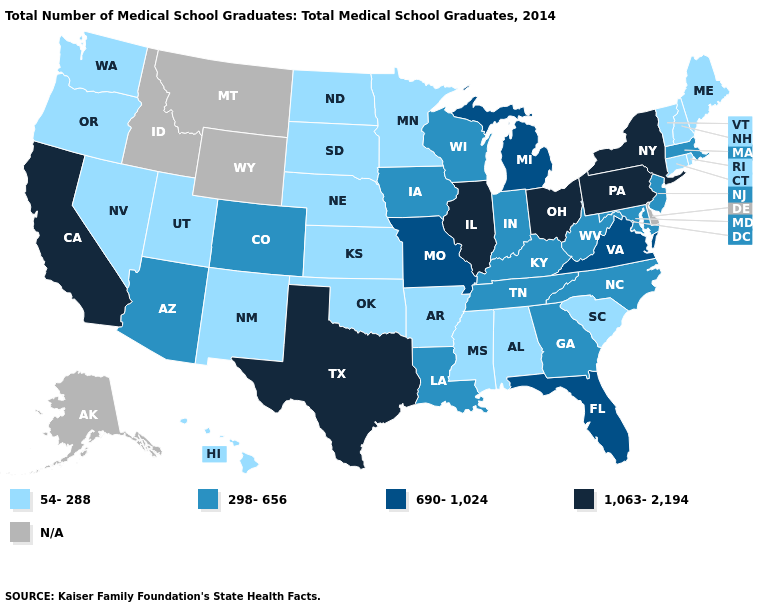How many symbols are there in the legend?
Be succinct. 5. Name the states that have a value in the range N/A?
Give a very brief answer. Alaska, Delaware, Idaho, Montana, Wyoming. What is the value of South Carolina?
Concise answer only. 54-288. What is the value of Nevada?
Be succinct. 54-288. Which states have the highest value in the USA?
Give a very brief answer. California, Illinois, New York, Ohio, Pennsylvania, Texas. Name the states that have a value in the range 690-1,024?
Quick response, please. Florida, Michigan, Missouri, Virginia. Name the states that have a value in the range 298-656?
Short answer required. Arizona, Colorado, Georgia, Indiana, Iowa, Kentucky, Louisiana, Maryland, Massachusetts, New Jersey, North Carolina, Tennessee, West Virginia, Wisconsin. What is the value of Rhode Island?
Give a very brief answer. 54-288. Name the states that have a value in the range 1,063-2,194?
Short answer required. California, Illinois, New York, Ohio, Pennsylvania, Texas. What is the value of Illinois?
Short answer required. 1,063-2,194. What is the value of Nebraska?
Concise answer only. 54-288. What is the highest value in the USA?
Keep it brief. 1,063-2,194. Does the first symbol in the legend represent the smallest category?
Give a very brief answer. Yes. 